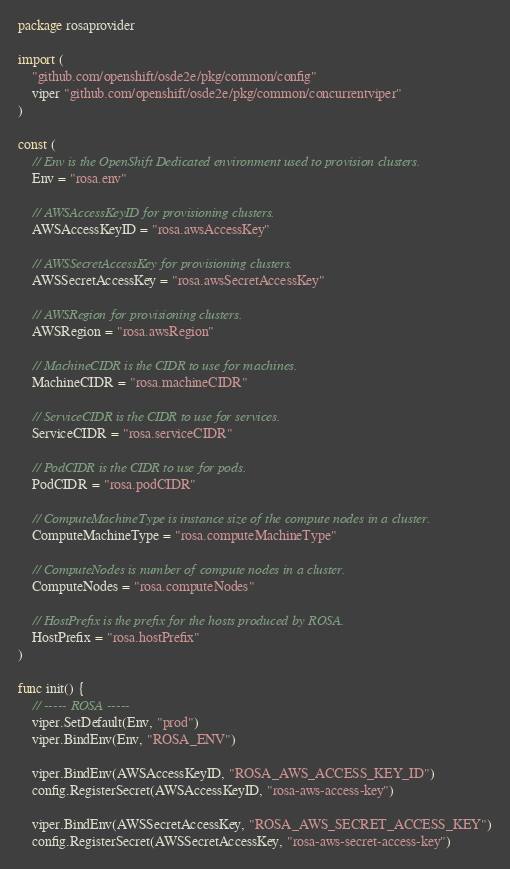Convert code to text. <code><loc_0><loc_0><loc_500><loc_500><_Go_>package rosaprovider

import (
	"github.com/openshift/osde2e/pkg/common/config"
	viper "github.com/openshift/osde2e/pkg/common/concurrentviper"
)

const (
	// Env is the OpenShift Dedicated environment used to provision clusters.
	Env = "rosa.env"

	// AWSAccessKeyID for provisioning clusters.
	AWSAccessKeyID = "rosa.awsAccessKey"

	// AWSSecretAccessKey for provisioning clusters.
	AWSSecretAccessKey = "rosa.awsSecretAccessKey"

	// AWSRegion for provisioning clusters.
	AWSRegion = "rosa.awsRegion"

	// MachineCIDR is the CIDR to use for machines.
	MachineCIDR = "rosa.machineCIDR"

	// ServiceCIDR is the CIDR to use for services.
	ServiceCIDR = "rosa.serviceCIDR"

	// PodCIDR is the CIDR to use for pods.
	PodCIDR = "rosa.podCIDR"

	// ComputeMachineType is instance size of the compute nodes in a cluster.
	ComputeMachineType = "rosa.computeMachineType"

	// ComputeNodes is number of compute nodes in a cluster.
	ComputeNodes = "rosa.computeNodes"

	// HostPrefix is the prefix for the hosts produced by ROSA.
	HostPrefix = "rosa.hostPrefix"
)

func init() {
	// ----- ROSA -----
	viper.SetDefault(Env, "prod")
	viper.BindEnv(Env, "ROSA_ENV")

	viper.BindEnv(AWSAccessKeyID, "ROSA_AWS_ACCESS_KEY_ID")
	config.RegisterSecret(AWSAccessKeyID, "rosa-aws-access-key")

	viper.BindEnv(AWSSecretAccessKey, "ROSA_AWS_SECRET_ACCESS_KEY")
	config.RegisterSecret(AWSSecretAccessKey, "rosa-aws-secret-access-key")
</code> 